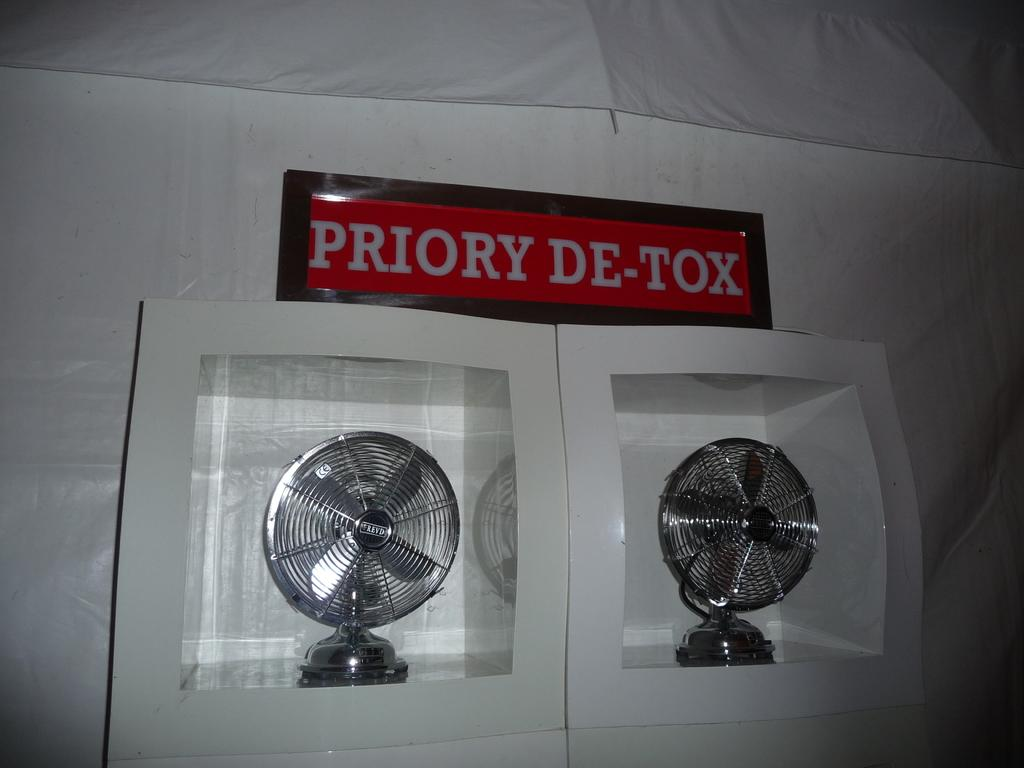What type of objects can be seen in the image? There are fans in the image. What structure is present in the image? There is a tent in the image. What force is being applied to the tent in the image? There is no indication of any force being applied to the tent in the image. What hope does the presence of the fans in the image represent? The presence of the fans in the image does not represent any hope; they are simply objects in the image. 